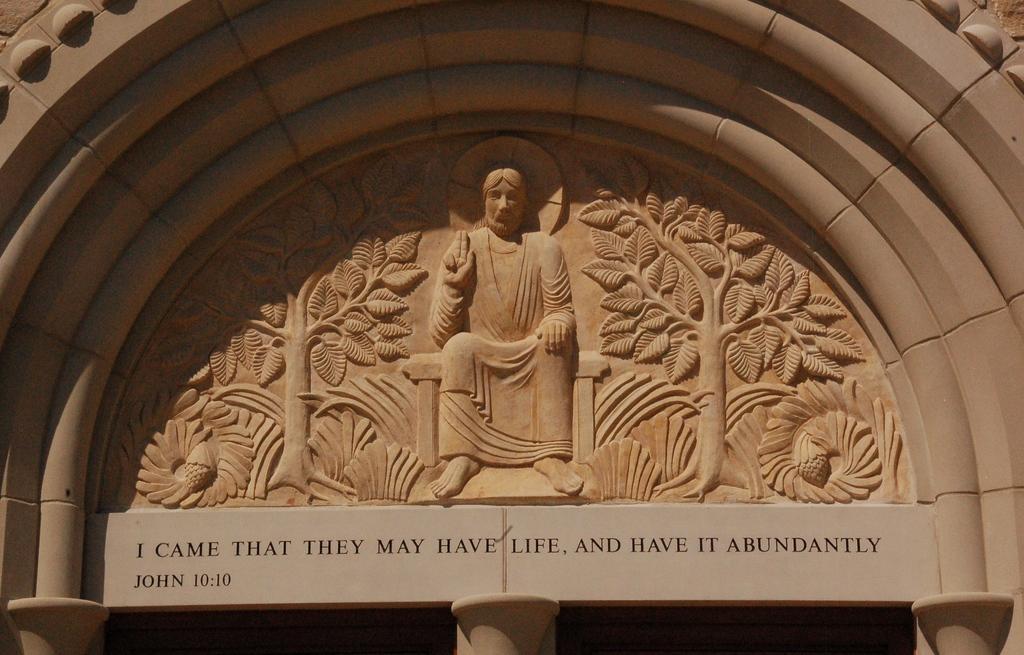Describe this image in one or two sentences. In this picture we can see a sculpture and some text on the wall. 